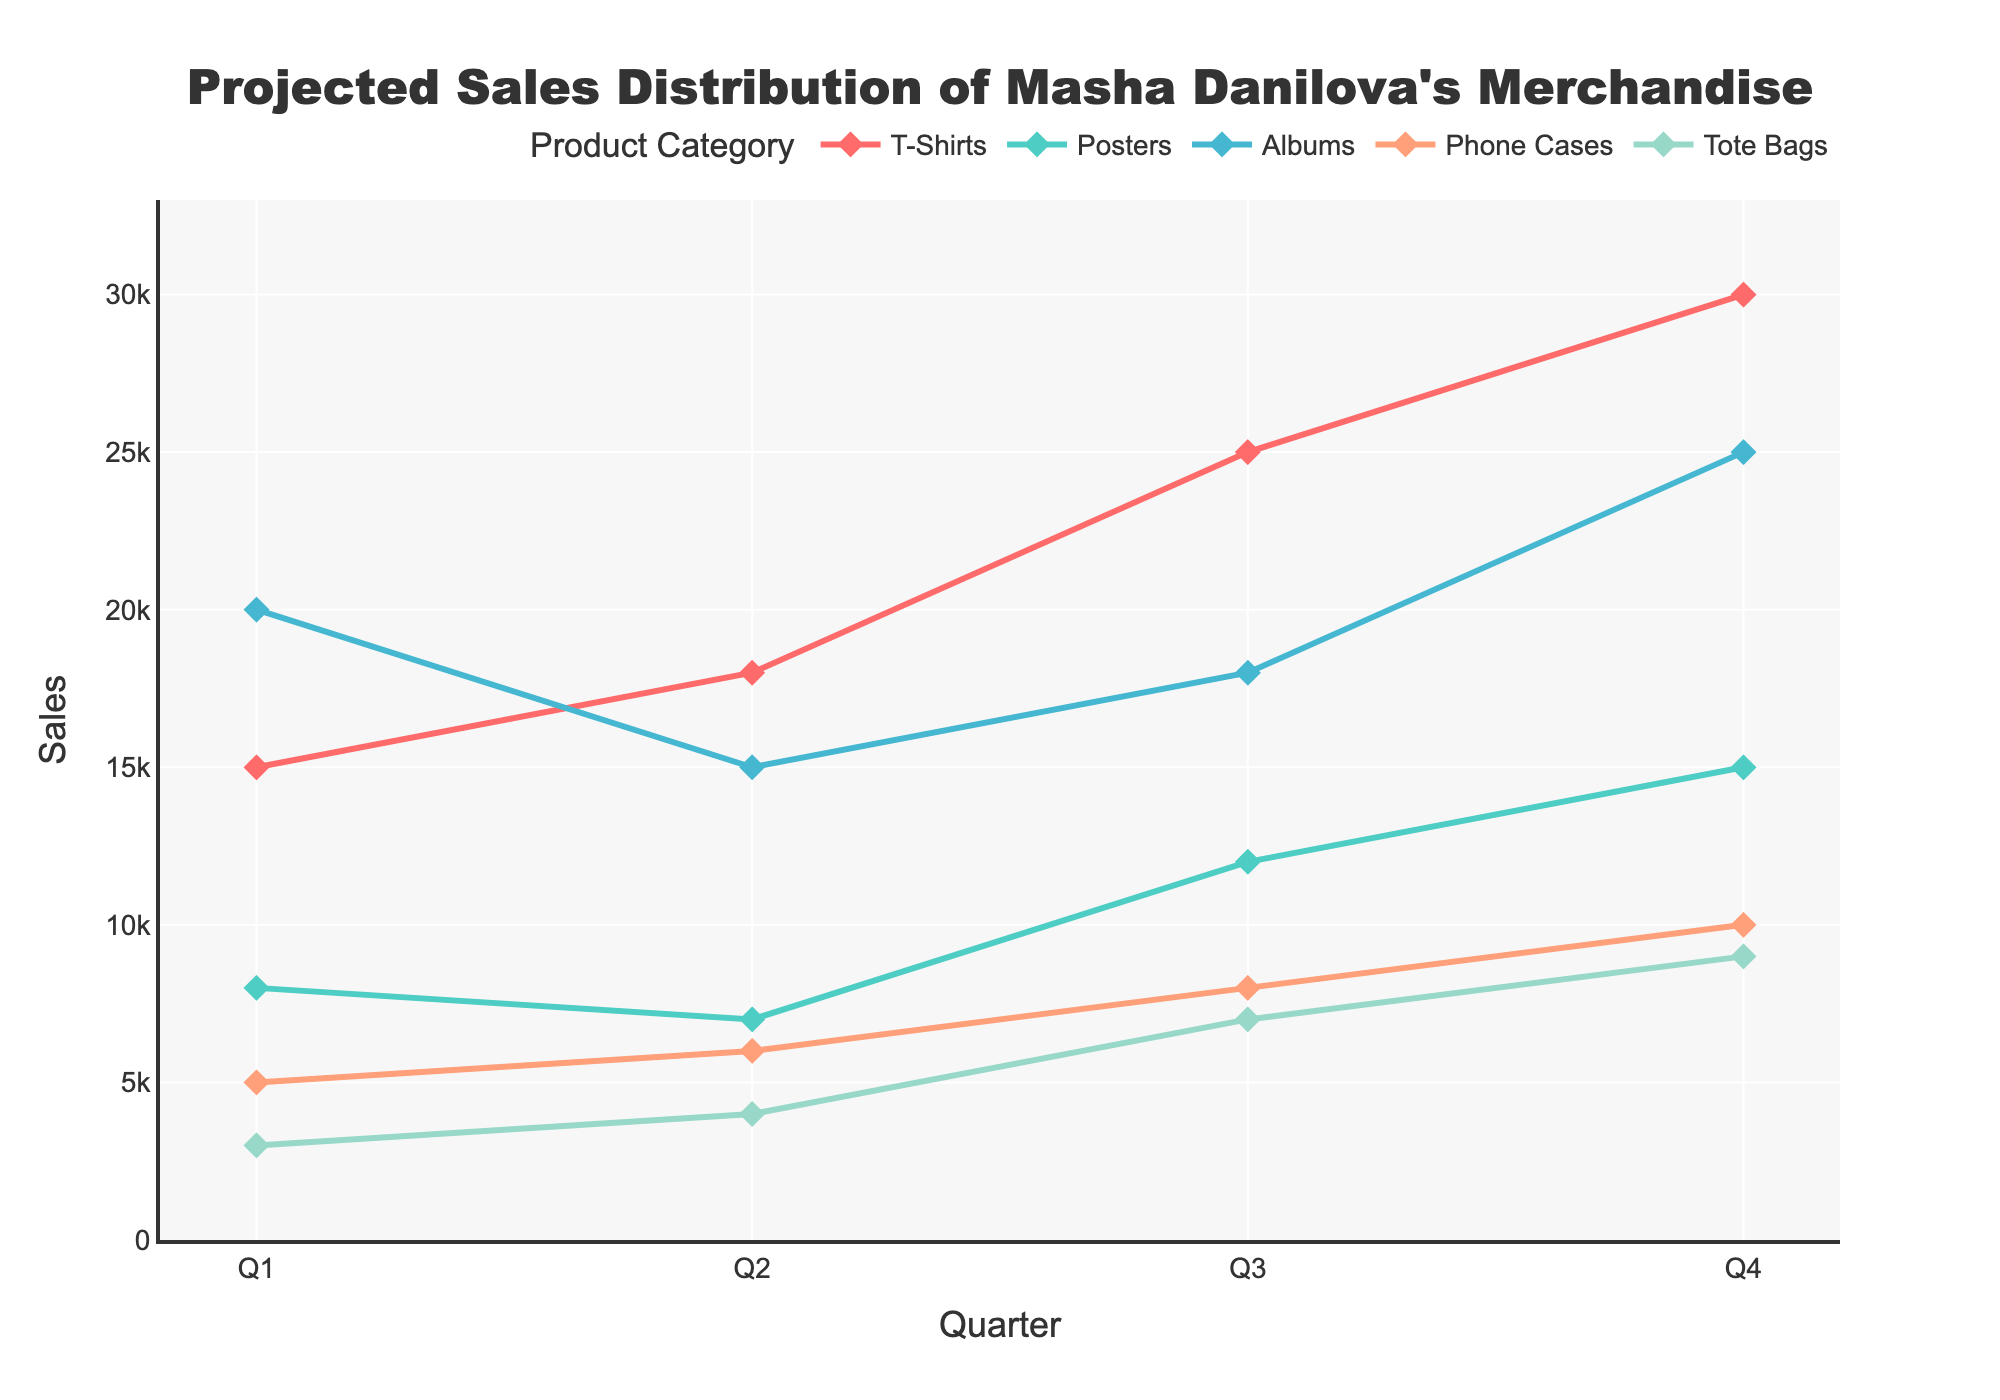What is the overall title of the figure? The title is prominently displayed at the top center of the figure in a large font. It reads "Projected Sales Distribution of Masha Danilova's Merchandise."
Answer: Projected Sales Distribution of Masha Danilova's Merchandise What are the product categories included in the figure? The legend at the top of the figure shows the product categories, which include T-Shirts, Posters, Albums, Phone Cases, and Tote Bags.
Answer: T-Shirts, Posters, Albums, Phone Cases, Tote Bags In which quarter are T-shirt sales projected to be the highest? By examining the line representing T-shirts, the peak value occurs in Q4, where it reaches 30,000.
Answer: Q4 What is the projected range of sales for Phone Cases across all quarters? The projected sales of Phone Cases are observed at 5,000 in Q1, 6,000 in Q2, 8,000 in Q3, and 10,000 in Q4. These values range from 5,000 to 10,000.
Answer: 5,000-10,000 Which two product categories have the most significant difference in projected sales in Q4? By comparing all categories in Q4, T-Shirts and Tote Bags have the highest individual sales at 30,000 and lowest at 9,000 respectively. The difference is 21,000.
Answer: T-Shirts and Tote Bags What is the total projected sales of Posters in the first half of the year? Posters sales in Q1 and Q2 are 8,000 and 7,000, respectively. Adding these numbers up gives the total sales for the first half of the year as 8,000 + 7,000 = 15,000.
Answer: 15,000 How do the sales of Albums compare between Q2 and Q3? The sales of Albums in Q2 is 15,000 and in Q3 is 18,000. Comparing these values, the sales in Q3 are higher by 3,000 units.
Answer: Q3 is higher by 3,000 Which quarter demonstrates the highest variability in sales across all merchandise categories? To find the highest variability, compare the range of sales in each quarter. Q4 shows the highest variability with T-Shirts at 30,000 and Tote Bags at 9,000, resulting in a 21,000 unit difference.
Answer: Q4 